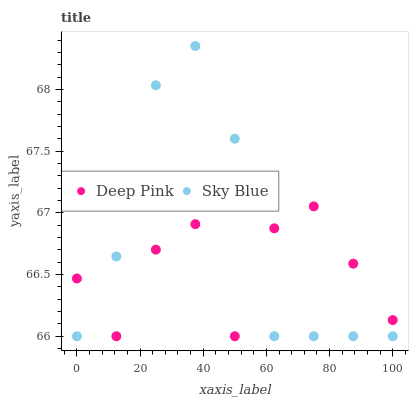Does Deep Pink have the minimum area under the curve?
Answer yes or no. Yes. Does Sky Blue have the maximum area under the curve?
Answer yes or no. Yes. Does Deep Pink have the maximum area under the curve?
Answer yes or no. No. Is Sky Blue the smoothest?
Answer yes or no. Yes. Is Deep Pink the roughest?
Answer yes or no. Yes. Is Deep Pink the smoothest?
Answer yes or no. No. Does Sky Blue have the lowest value?
Answer yes or no. Yes. Does Sky Blue have the highest value?
Answer yes or no. Yes. Does Deep Pink have the highest value?
Answer yes or no. No. Does Sky Blue intersect Deep Pink?
Answer yes or no. Yes. Is Sky Blue less than Deep Pink?
Answer yes or no. No. Is Sky Blue greater than Deep Pink?
Answer yes or no. No. 